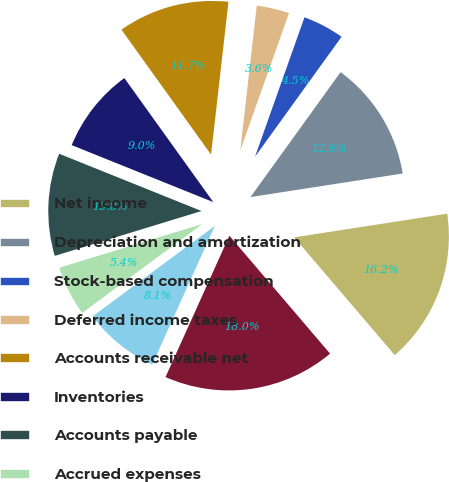Convert chart. <chart><loc_0><loc_0><loc_500><loc_500><pie_chart><fcel>Net income<fcel>Depreciation and amortization<fcel>Stock-based compensation<fcel>Deferred income taxes<fcel>Accounts receivable net<fcel>Inventories<fcel>Accounts payable<fcel>Accrued expenses<fcel>Other assets and liabilities<fcel>Net cash provided by operating<nl><fcel>16.2%<fcel>12.61%<fcel>4.52%<fcel>3.62%<fcel>11.71%<fcel>9.01%<fcel>10.81%<fcel>5.42%<fcel>8.11%<fcel>18.0%<nl></chart> 